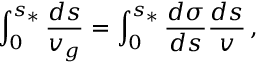Convert formula to latex. <formula><loc_0><loc_0><loc_500><loc_500>\int _ { 0 } ^ { s _ { * } } \frac { d s } { v _ { g } } = \int _ { 0 } ^ { s _ { * } } \frac { d \sigma } { d s } \frac { d s } { v } \, ,</formula> 